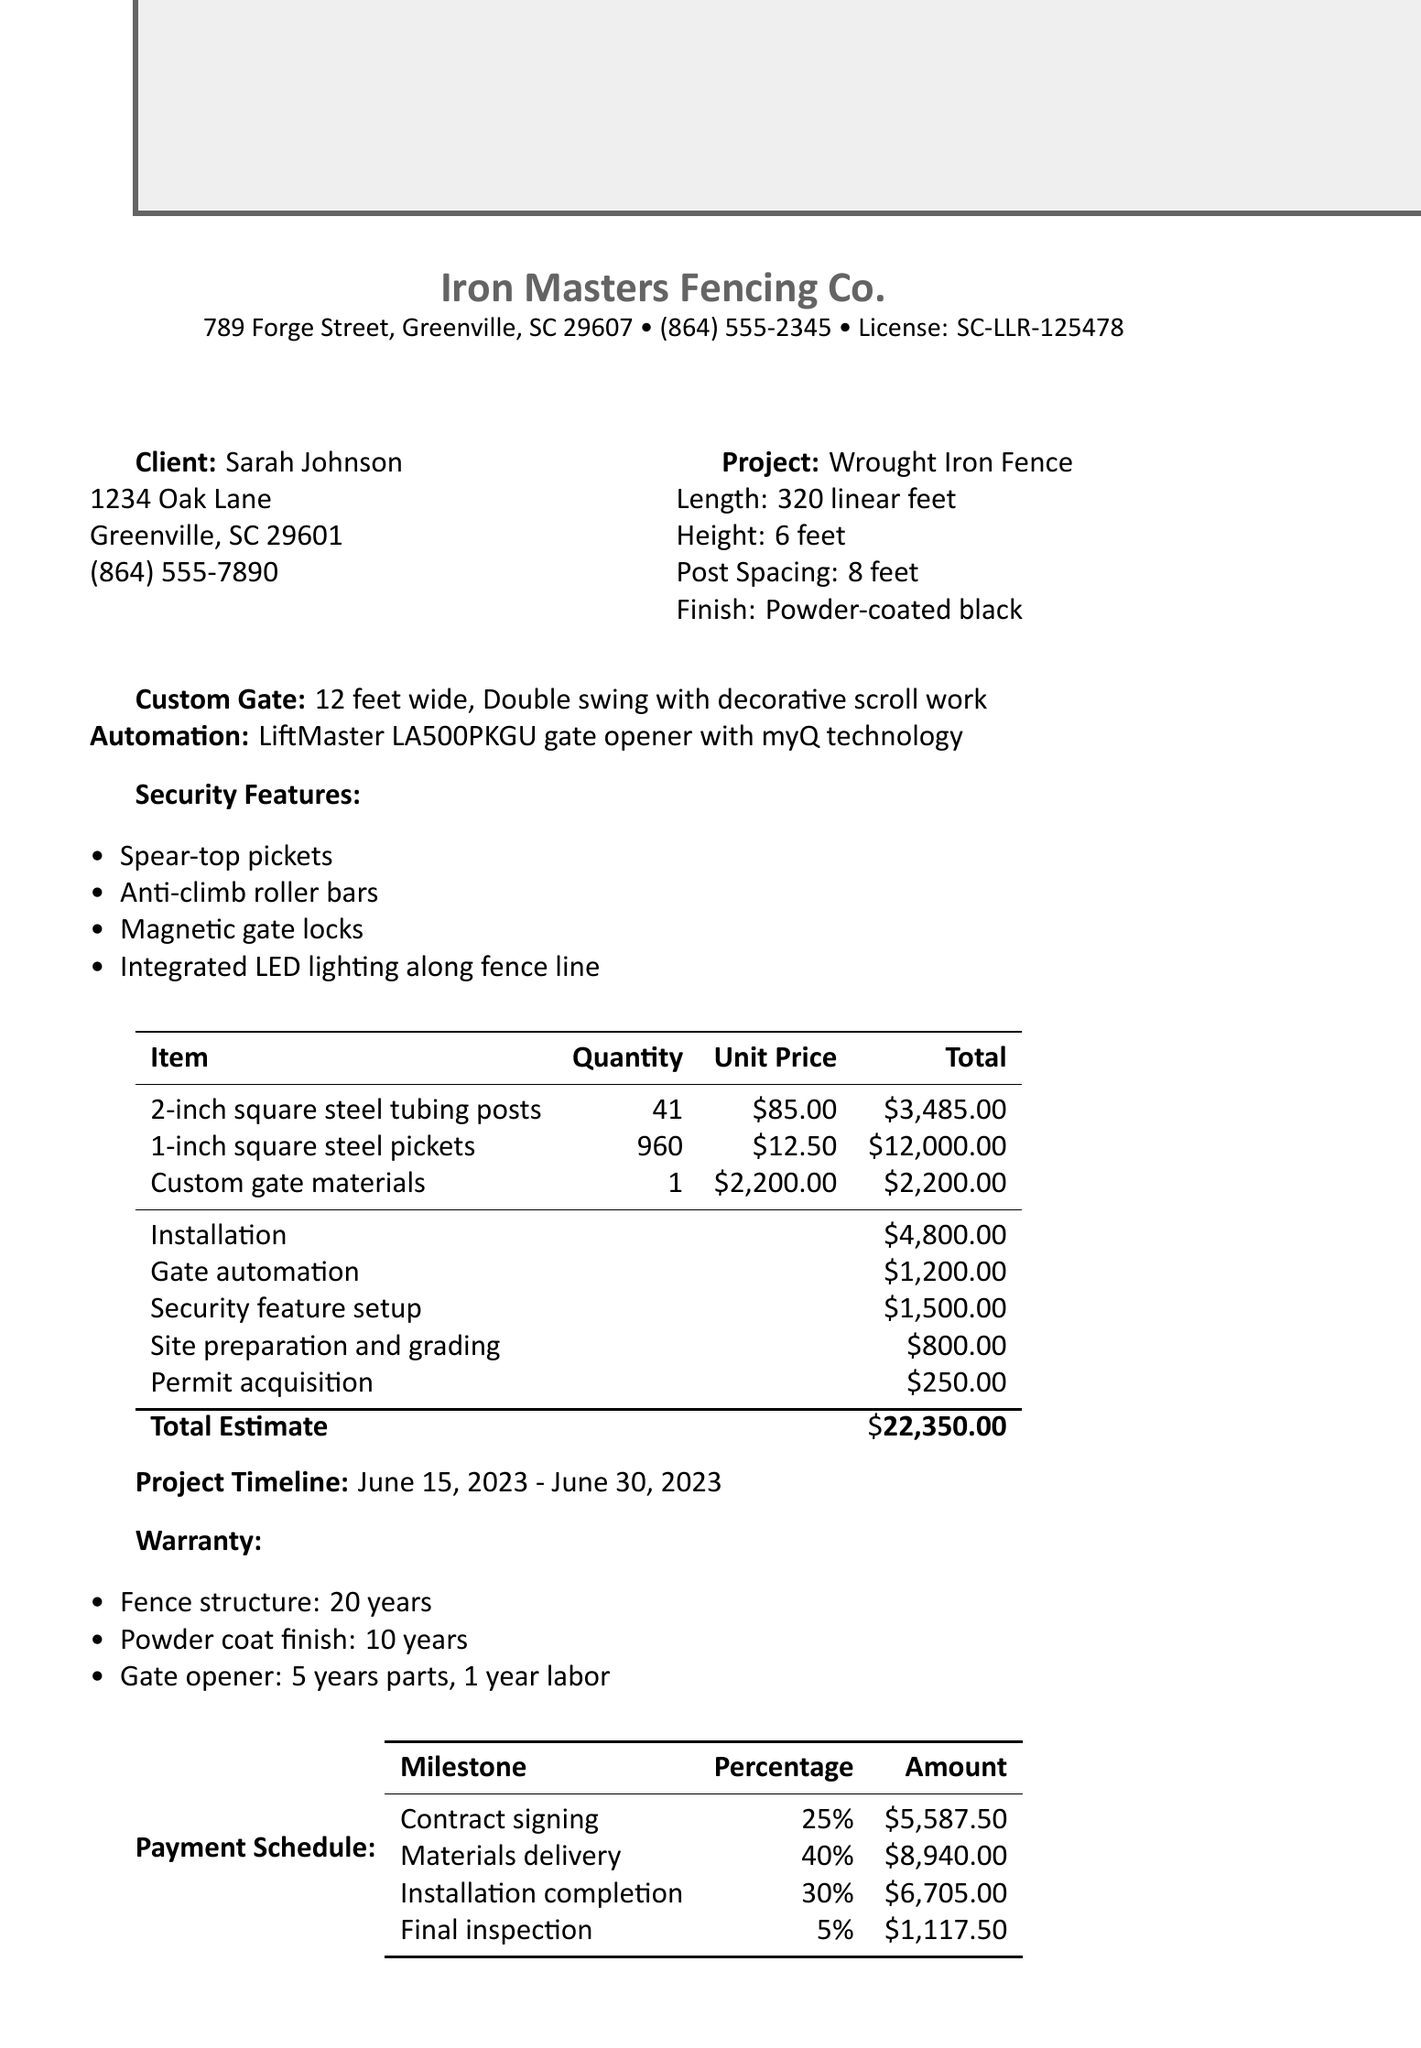What is the total estimate for the project? The total estimate for the project is detailed at the end of the document.
Answer: $22,350.00 When is the estimated completion date? The estimated completion date can be found in the timeline section of the document.
Answer: June 30, 2023 What is the height of the fence? The height of the fence is provided in the project details section of the document.
Answer: 6 feet What type of automation is included for the gate? The type of automation is specified in the custom gate section of the document.
Answer: LiftMaster LA500PKGU gate opener with myQ technology How long is the warranty for the fence structure? The warranty information can be found in the warranty section of the document.
Answer: 20 years What is the quantity of the 2-inch square steel tubing posts? The quantity is listed in the materials section.
Answer: 41 What client milestone percentage is due at contract signing? The payment schedule outlines the percentage due at contract signing.
Answer: 25% What security feature is included for climbing prevention? The specific security features are detailed in the security features section.
Answer: Anti-climb roller bars What is the unit price for the custom gate materials? The unit price can be found in the materials section of the document.
Answer: $2,200.00 